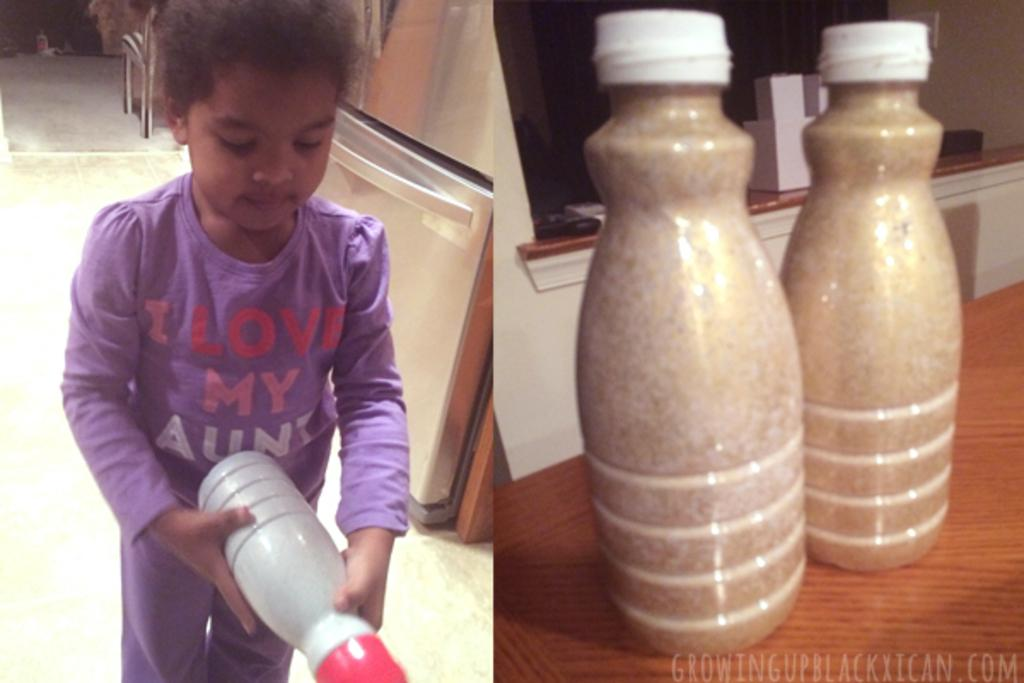What is the kid holding in the first image? In the first image, the kid is holding a bottle. How many bottles are visible in the second image? In the second image, there are two bottles on a table. What type of root can be seen growing from the bottle in the first image? There is no root growing from the bottle in the first image; it is a kid holding a bottle. How does the zipper affect the bottles in the second image? There is no mention of a zipper in either image, so it cannot affect the bottles. 